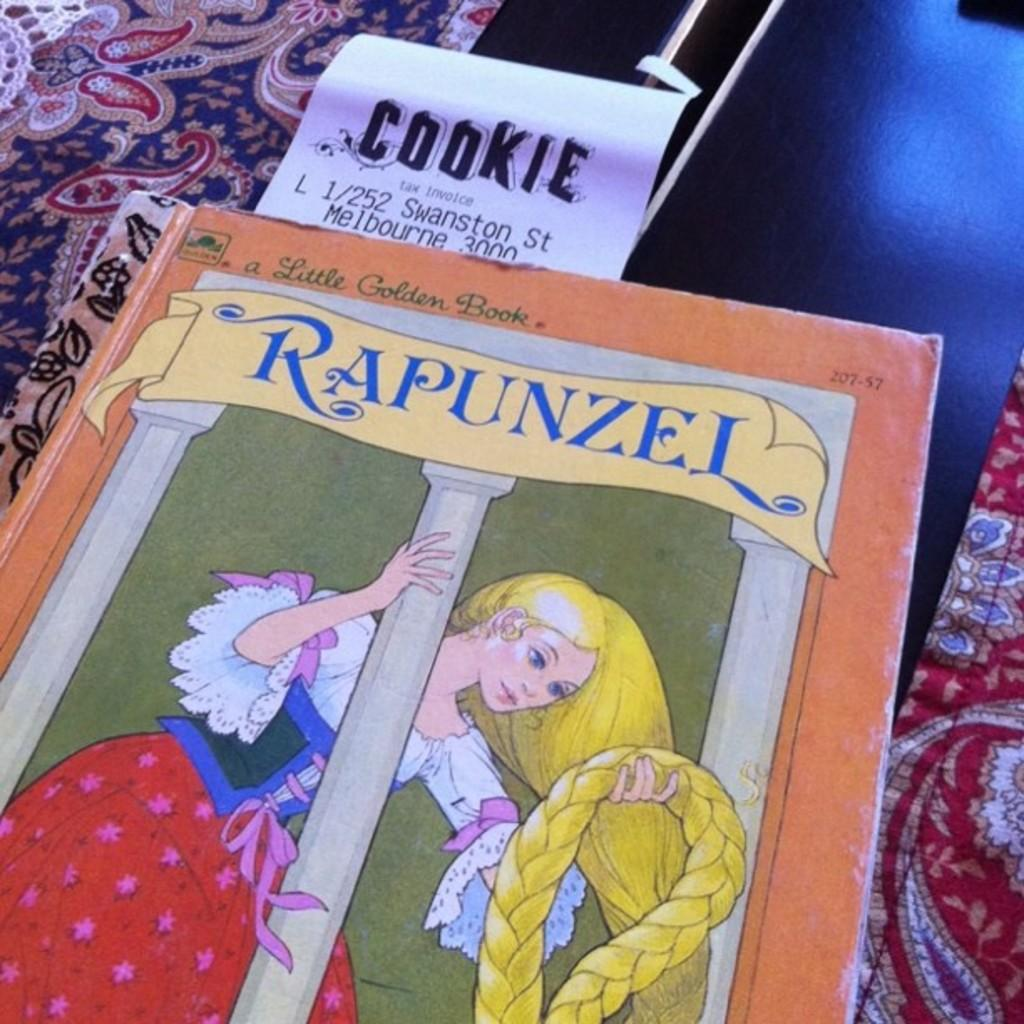<image>
Render a clear and concise summary of the photo. A Rapunzel book shows a girl with long blonde hair. 